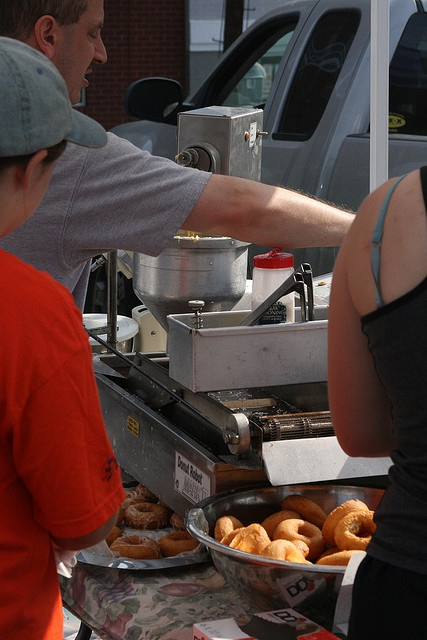Describe the objects in this image and their specific colors. I can see people in black, maroon, and purple tones, truck in black, gray, darkgray, and purple tones, car in black, gray, and purple tones, people in black, maroon, and brown tones, and people in black, gray, and maroon tones in this image. 